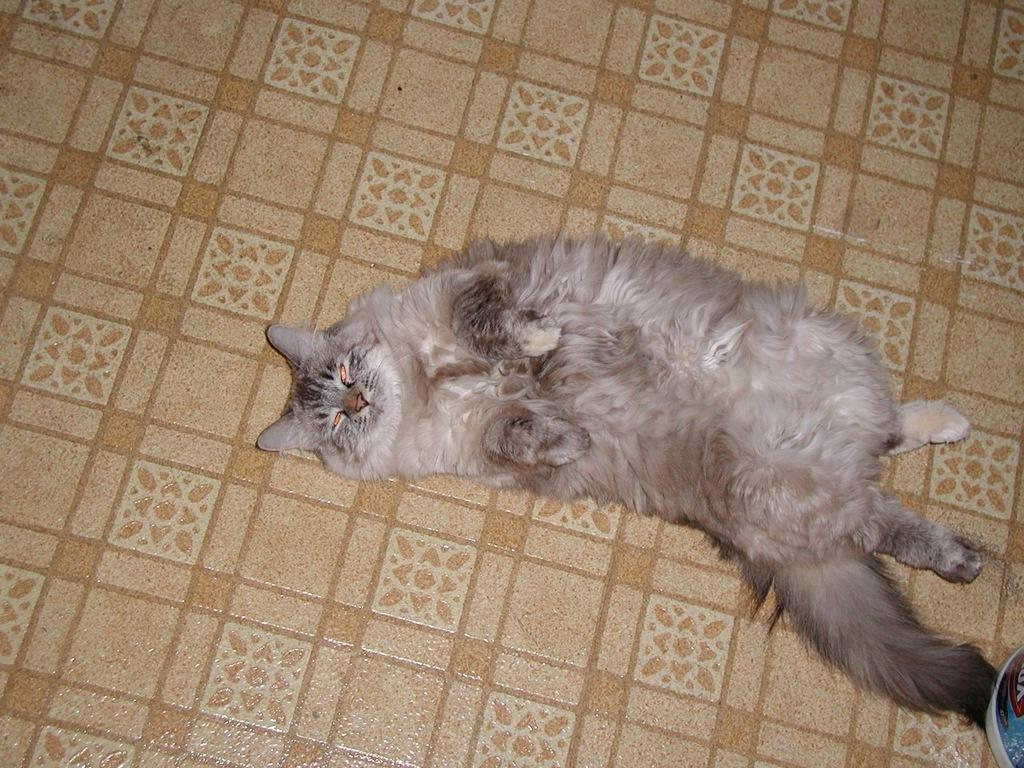What animal can be seen in the image? There is a cat laying on the floor in the image. What is located in the bottom right of the image? There is an object in the bottom right of the image. Can you describe the colors of the object? The object is white and blue in color. What is written on the object? There is text written on the object. How many balls can be seen rolling on the floor in the image? There are no balls visible in the image; it features a cat laying on the floor and an object in the bottom right corner. What type of grain is being harvested in the background of the image? There is no background or harvesting activity depicted in the image; it only shows a cat and an object. 